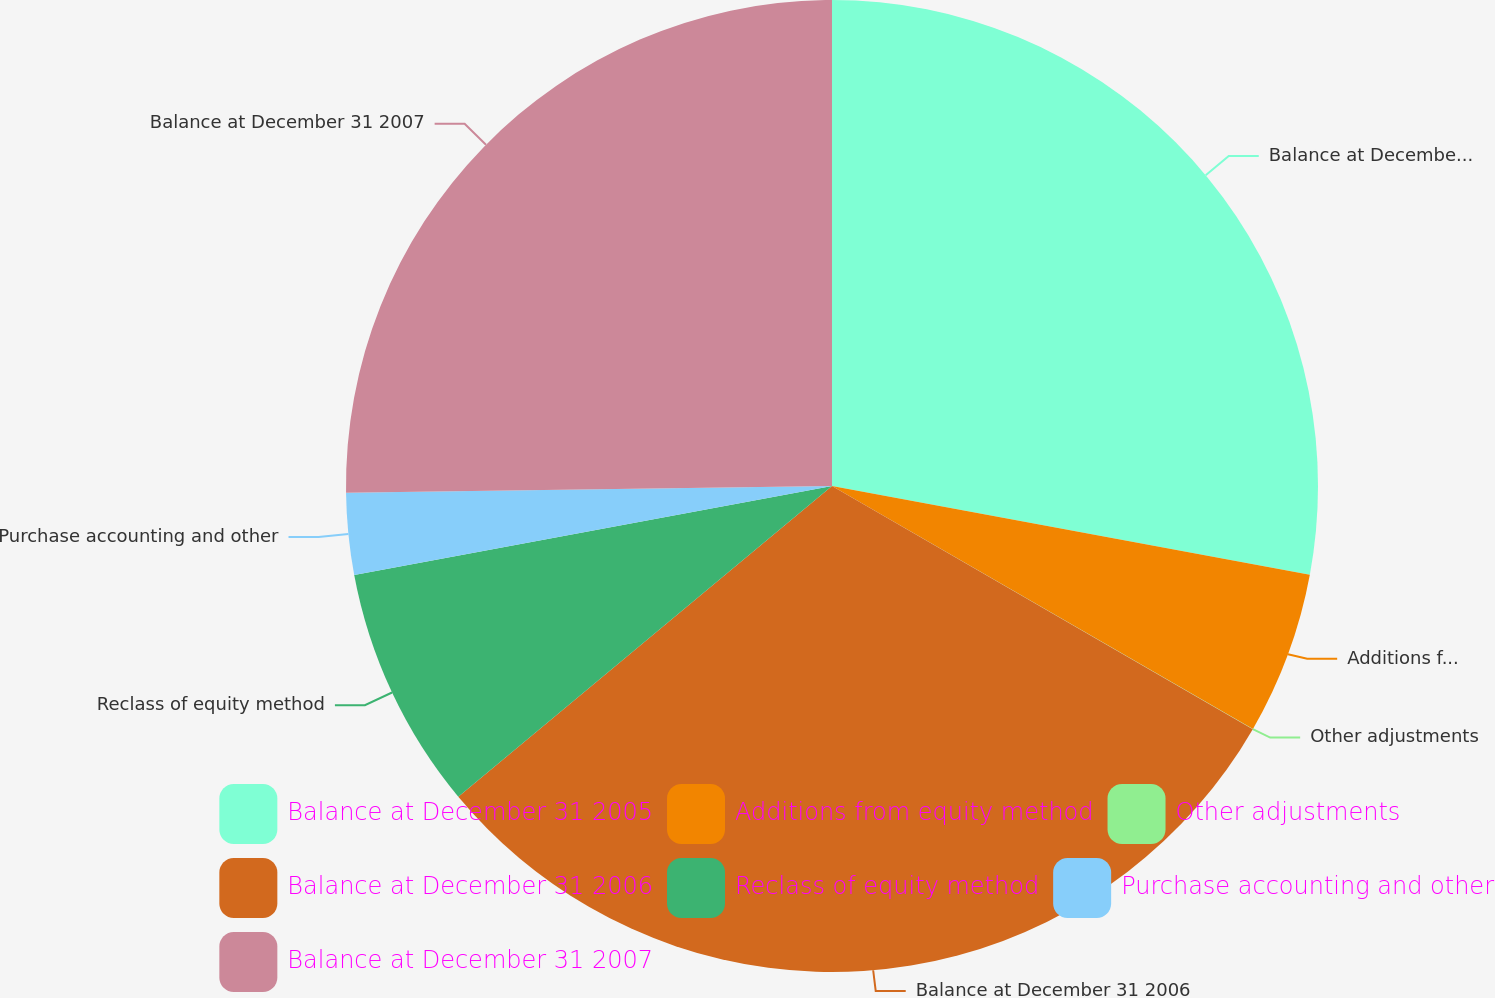<chart> <loc_0><loc_0><loc_500><loc_500><pie_chart><fcel>Balance at December 31 2005<fcel>Additions from equity method<fcel>Other adjustments<fcel>Balance at December 31 2006<fcel>Reclass of equity method<fcel>Purchase accounting and other<fcel>Balance at December 31 2007<nl><fcel>27.92%<fcel>5.41%<fcel>0.01%<fcel>30.62%<fcel>8.11%<fcel>2.71%<fcel>25.22%<nl></chart> 